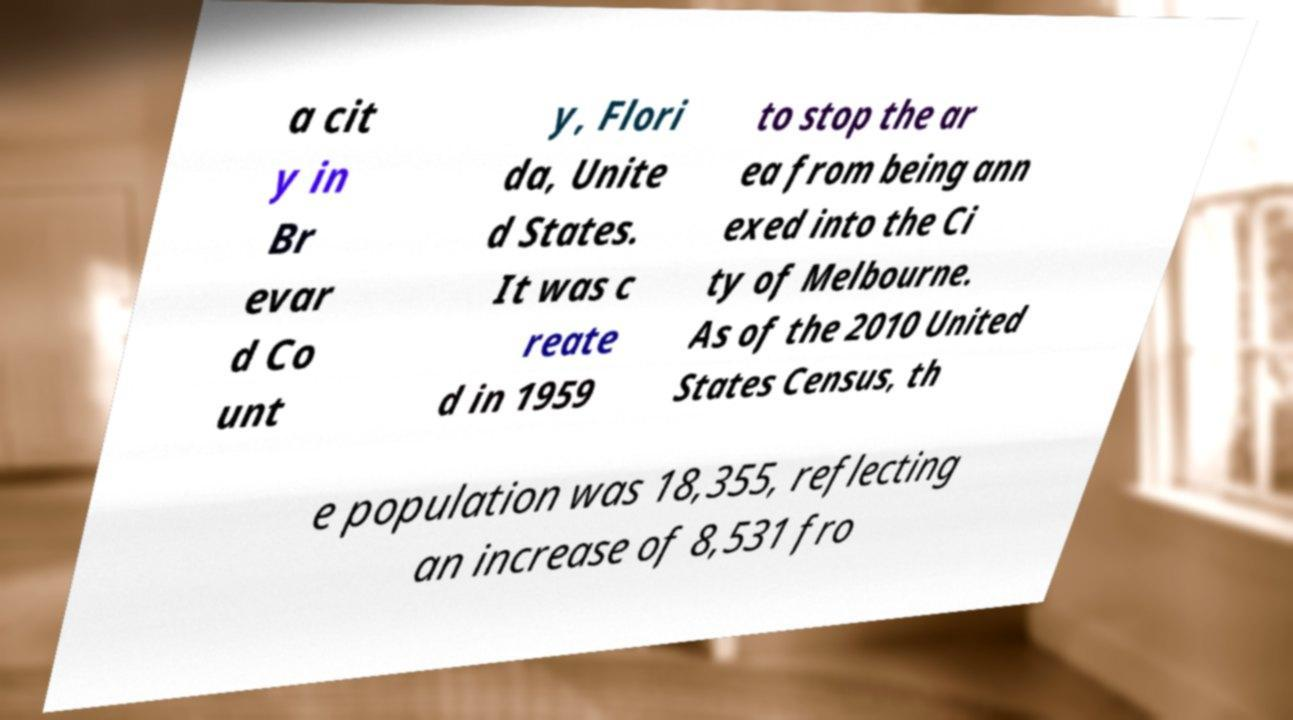I need the written content from this picture converted into text. Can you do that? a cit y in Br evar d Co unt y, Flori da, Unite d States. It was c reate d in 1959 to stop the ar ea from being ann exed into the Ci ty of Melbourne. As of the 2010 United States Census, th e population was 18,355, reflecting an increase of 8,531 fro 